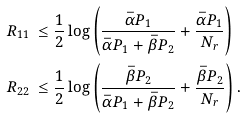Convert formula to latex. <formula><loc_0><loc_0><loc_500><loc_500>R _ { 1 1 } & \, \leq \frac { 1 } { 2 } \log \left ( \frac { \bar { \alpha } P _ { 1 } } { \bar { \alpha } P _ { 1 } + \bar { \beta } P _ { 2 } } + \frac { \bar { \alpha } P _ { 1 } } { N _ { r } } \right ) \\ R _ { 2 2 } & \, \leq \frac { 1 } { 2 } \log \left ( \frac { \bar { \beta } P _ { 2 } } { \bar { \alpha } P _ { 1 } + \bar { \beta } P _ { 2 } } + \frac { \bar { \beta } P _ { 2 } } { N _ { r } } \right ) .</formula> 